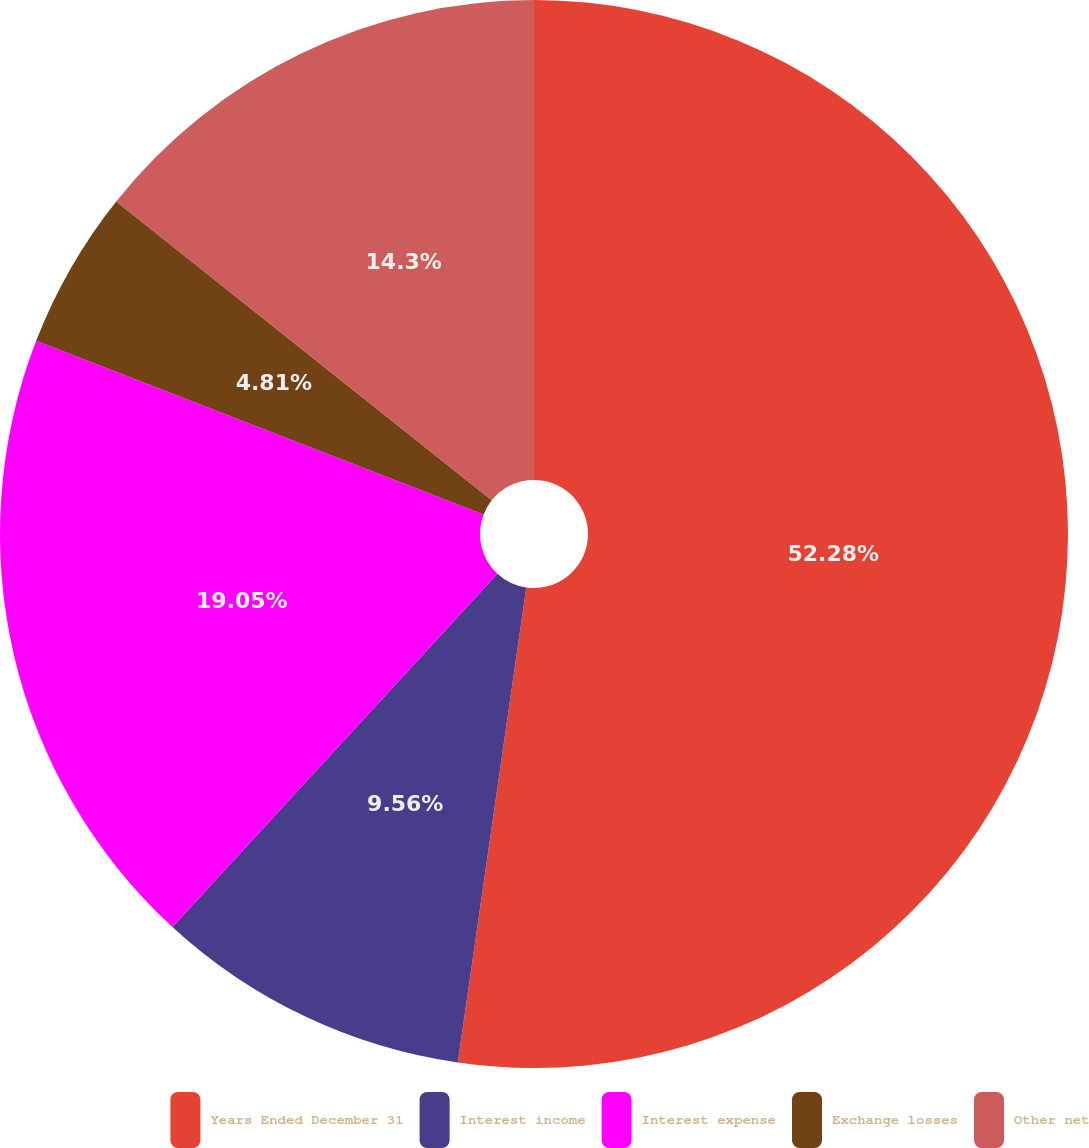Convert chart. <chart><loc_0><loc_0><loc_500><loc_500><pie_chart><fcel>Years Ended December 31<fcel>Interest income<fcel>Interest expense<fcel>Exchange losses<fcel>Other net<nl><fcel>52.28%<fcel>9.56%<fcel>19.05%<fcel>4.81%<fcel>14.3%<nl></chart> 